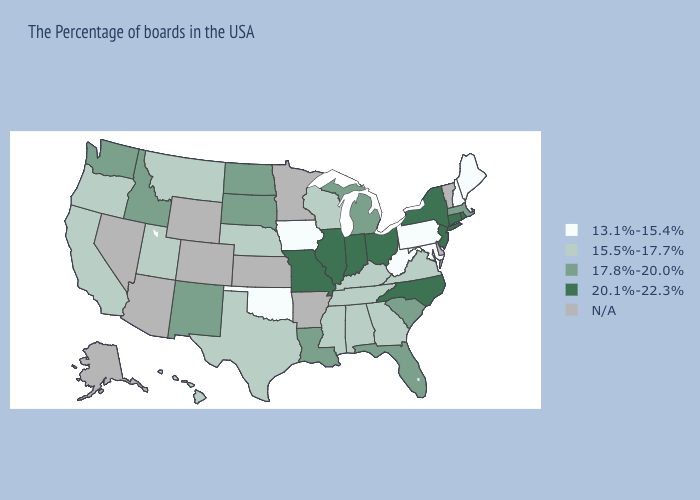Which states have the lowest value in the USA?
Short answer required. Maine, New Hampshire, Maryland, Pennsylvania, West Virginia, Iowa, Oklahoma. Which states have the lowest value in the USA?
Short answer required. Maine, New Hampshire, Maryland, Pennsylvania, West Virginia, Iowa, Oklahoma. Name the states that have a value in the range N/A?
Concise answer only. Vermont, Delaware, Arkansas, Minnesota, Kansas, Wyoming, Colorado, Arizona, Nevada, Alaska. Does Iowa have the lowest value in the MidWest?
Give a very brief answer. Yes. What is the value of New Mexico?
Be succinct. 17.8%-20.0%. What is the value of Michigan?
Give a very brief answer. 17.8%-20.0%. Name the states that have a value in the range N/A?
Give a very brief answer. Vermont, Delaware, Arkansas, Minnesota, Kansas, Wyoming, Colorado, Arizona, Nevada, Alaska. Does Wisconsin have the lowest value in the MidWest?
Answer briefly. No. Which states have the highest value in the USA?
Write a very short answer. Rhode Island, Connecticut, New York, New Jersey, North Carolina, Ohio, Indiana, Illinois, Missouri. Which states hav the highest value in the MidWest?
Write a very short answer. Ohio, Indiana, Illinois, Missouri. Name the states that have a value in the range 15.5%-17.7%?
Short answer required. Virginia, Georgia, Kentucky, Alabama, Tennessee, Wisconsin, Mississippi, Nebraska, Texas, Utah, Montana, California, Oregon, Hawaii. What is the value of Alabama?
Answer briefly. 15.5%-17.7%. Which states have the highest value in the USA?
Quick response, please. Rhode Island, Connecticut, New York, New Jersey, North Carolina, Ohio, Indiana, Illinois, Missouri. 